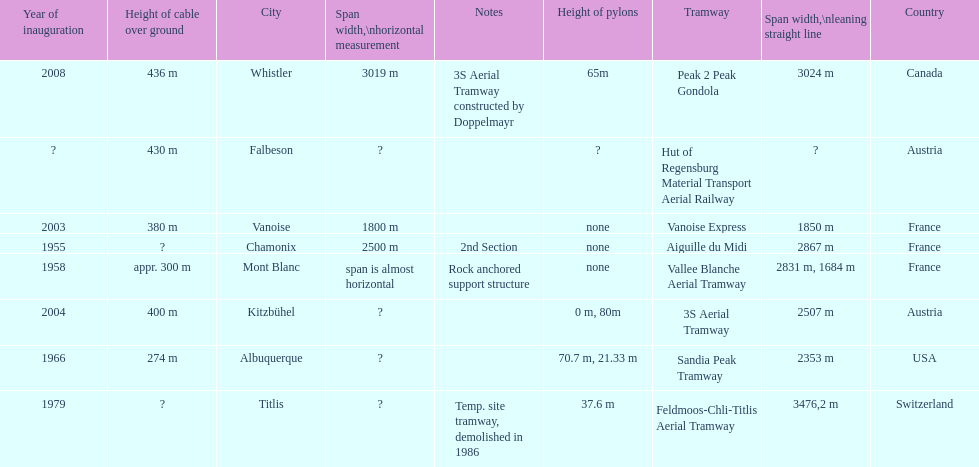Which tramway was built directly before the 3s aeriral tramway? Vanoise Express. 